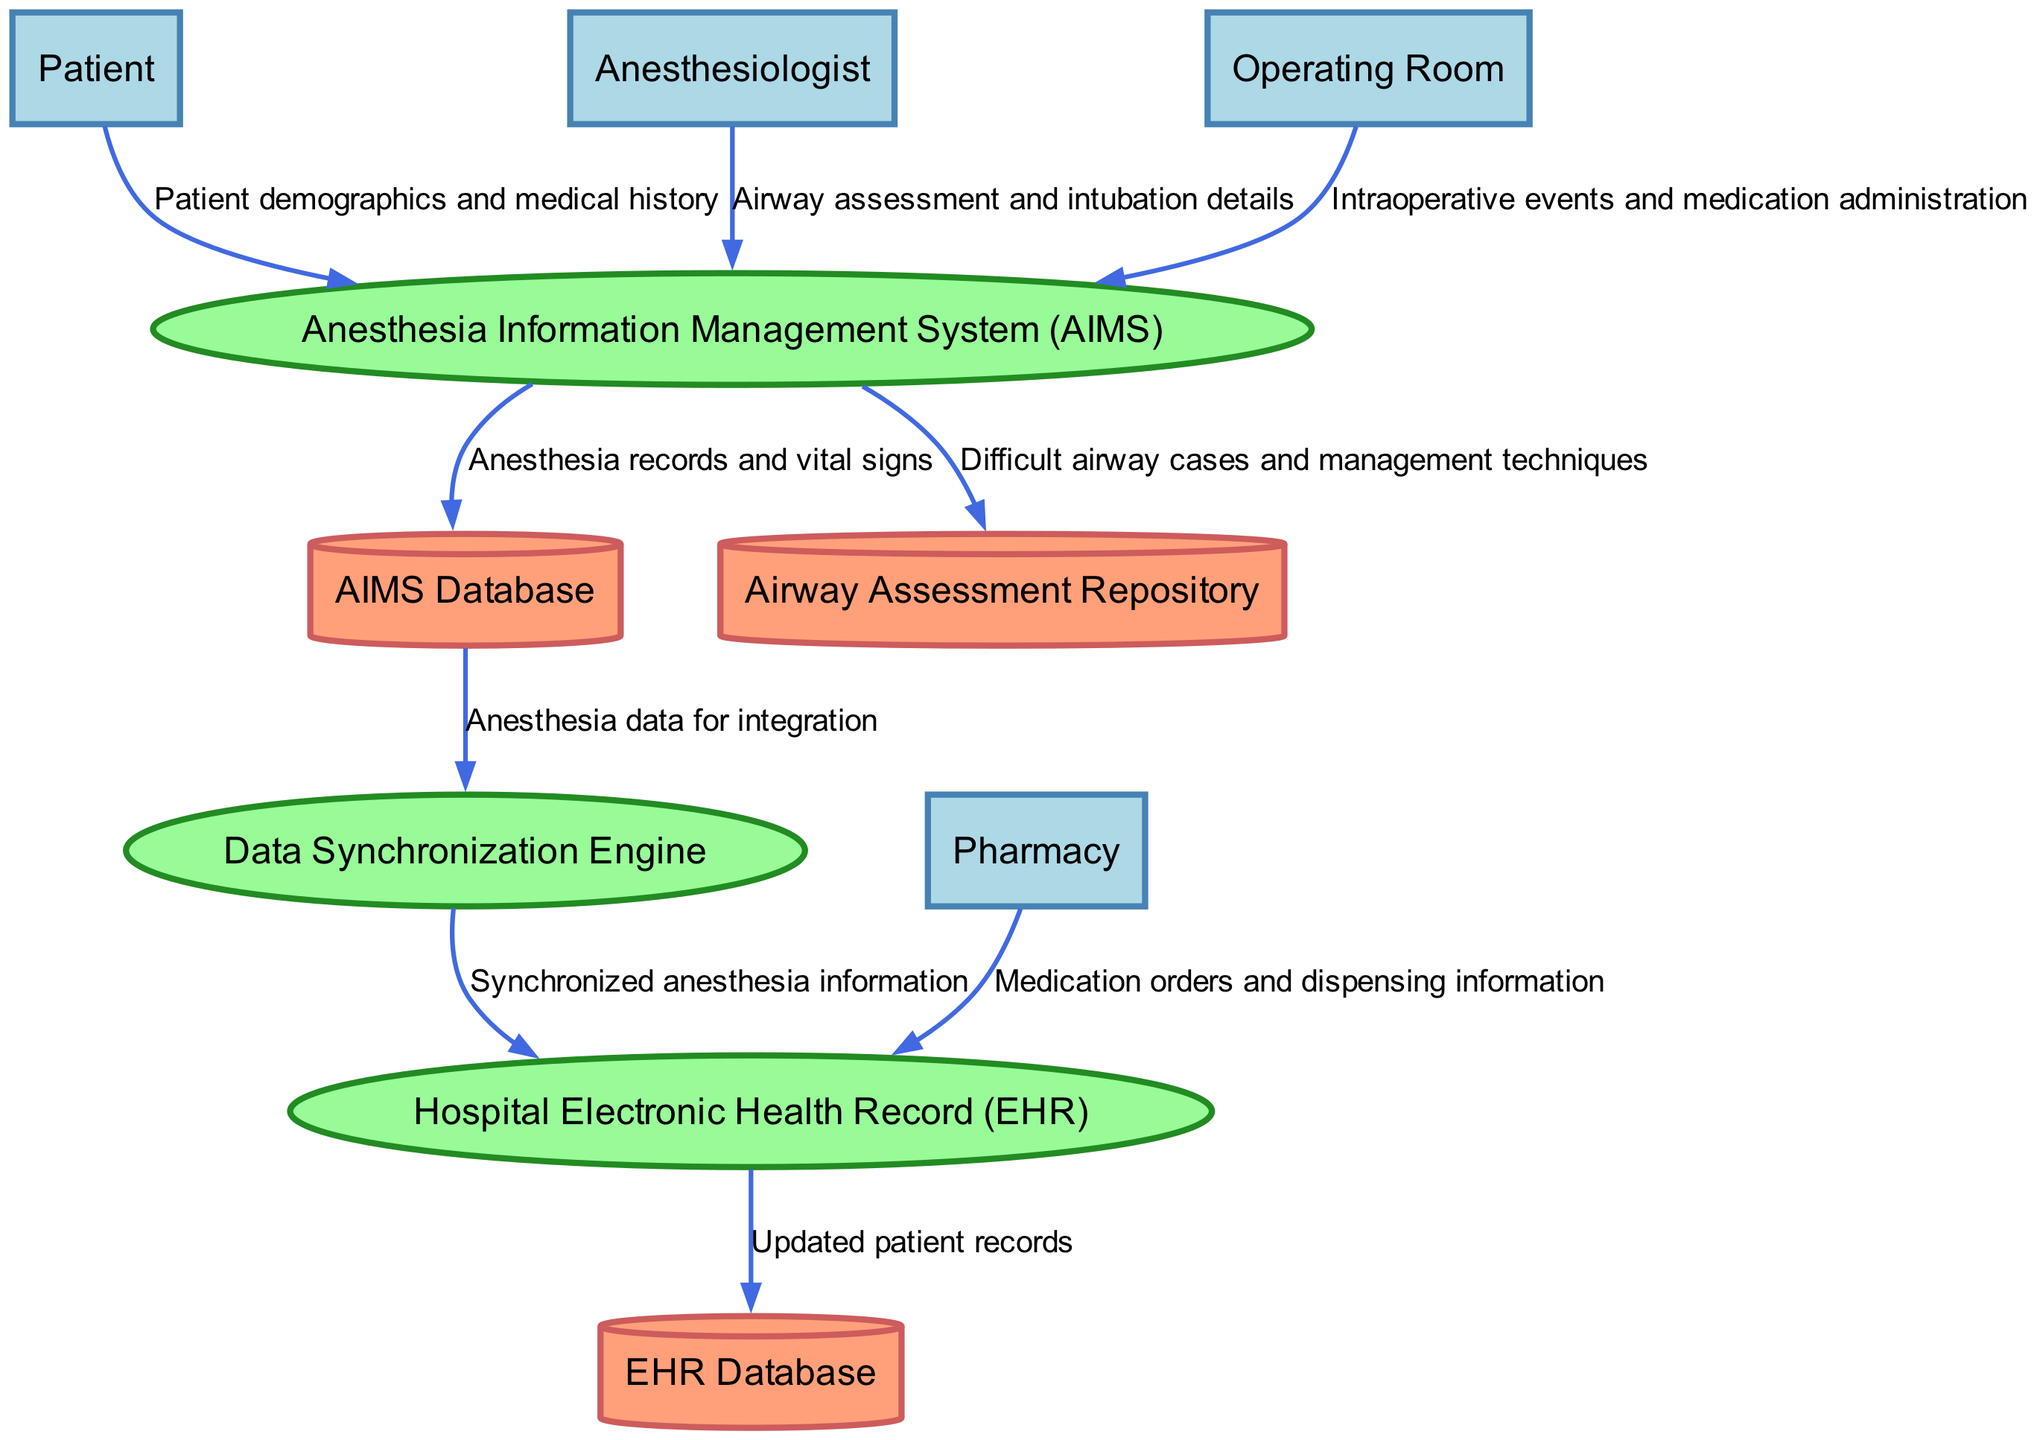What are the external entities involved in the data flow? The external entities in the diagram are Patient, Anesthesiologist, Operating Room, and Pharmacy. Each of these entities interacts with the processes within the system, providing or receiving data as outlined in the diagram.
Answer: Patient, Anesthesiologist, Operating Room, Pharmacy How many processes are defined in the diagram? The diagram contains three defined processes: Anesthesia Information Management System (AIMS), Hospital Electronic Health Record (EHR), and Data Synchronization Engine. Each of these processes plays a crucial role in handling and processing anesthesia-related data.
Answer: Three Which entity provides details of the airway assessment? The Anesthesiologist is responsible for providing the airway assessment and intubation details to the Anesthesia Information Management System (AIMS). This interaction is critical for documenting the management of difficult airways during procedures.
Answer: Anesthesiologist Where does the synchronized anesthesia information flow to? The synchronized anesthesia information flows from the Data Synchronization Engine to the Hospital Electronic Health Record (EHR). This step is essential for integrating anesthesia data into the patient's holistic medical record within the hospital system.
Answer: Hospital Electronic Health Record (EHR) What data is stored in the Airway Assessment Repository? The Airway Assessment Repository contains records of difficult airway cases and management techniques. This repository serves as a knowledge base for future reference and learning.
Answer: Difficult airway cases and management techniques What is the first data flow from the Patient? The first data flow from the Patient involves the transmission of patient demographics and medical history to the Anesthesia Information Management System (AIMS). This foundational data is crucial for planning anesthesia care.
Answer: Patient demographics and medical history How many data stores are mentioned in the diagram? There are three data stores identified in the diagram: AIMS Database, EHR Database, and Airway Assessment Repository. These data stores are locations where specific types of data are kept for access and retrieval.
Answer: Three What type of information does the Pharmacy send to the Hospital Electronic Health Record? The Pharmacy sends medication orders and dispensing information to the Hospital Electronic Health Record (EHR). This data flow is important for tracking medication use and ensuring patient safety.
Answer: Medication orders and dispensing information 